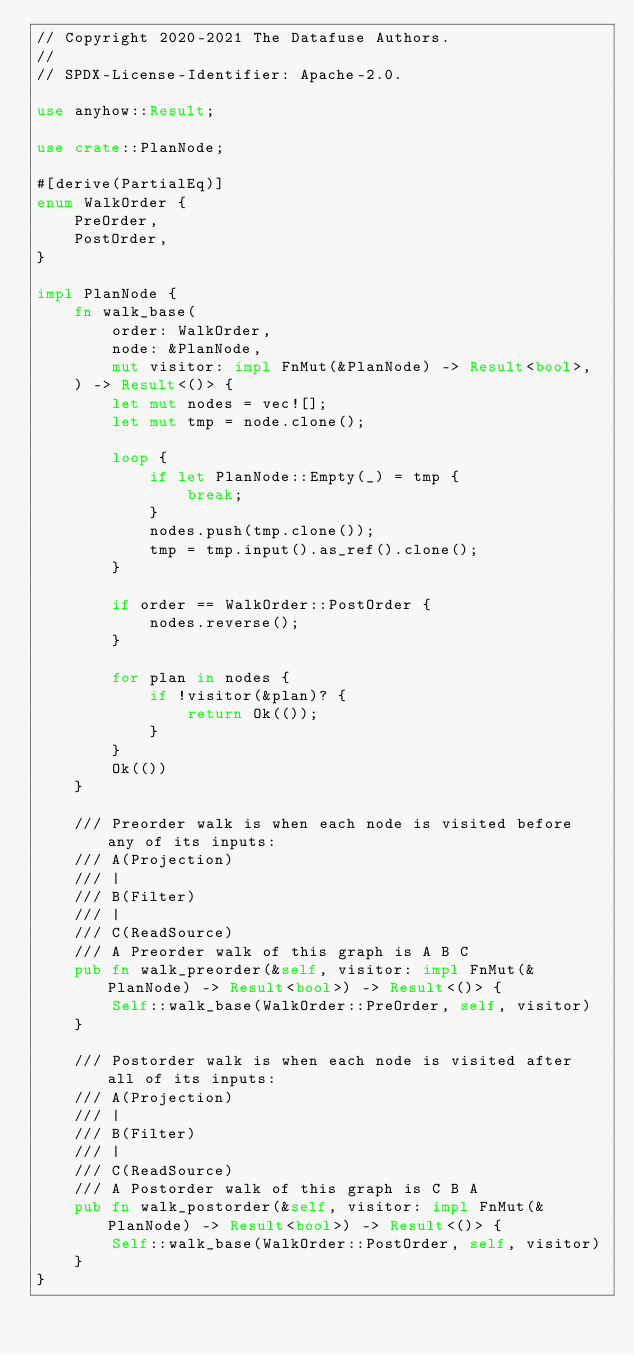Convert code to text. <code><loc_0><loc_0><loc_500><loc_500><_Rust_>// Copyright 2020-2021 The Datafuse Authors.
//
// SPDX-License-Identifier: Apache-2.0.

use anyhow::Result;

use crate::PlanNode;

#[derive(PartialEq)]
enum WalkOrder {
    PreOrder,
    PostOrder,
}

impl PlanNode {
    fn walk_base(
        order: WalkOrder,
        node: &PlanNode,
        mut visitor: impl FnMut(&PlanNode) -> Result<bool>,
    ) -> Result<()> {
        let mut nodes = vec![];
        let mut tmp = node.clone();

        loop {
            if let PlanNode::Empty(_) = tmp {
                break;
            }
            nodes.push(tmp.clone());
            tmp = tmp.input().as_ref().clone();
        }

        if order == WalkOrder::PostOrder {
            nodes.reverse();
        }

        for plan in nodes {
            if !visitor(&plan)? {
                return Ok(());
            }
        }
        Ok(())
    }

    /// Preorder walk is when each node is visited before any of its inputs:
    /// A(Projection)
    /// |
    /// B(Filter)
    /// |
    /// C(ReadSource)
    /// A Preorder walk of this graph is A B C
    pub fn walk_preorder(&self, visitor: impl FnMut(&PlanNode) -> Result<bool>) -> Result<()> {
        Self::walk_base(WalkOrder::PreOrder, self, visitor)
    }

    /// Postorder walk is when each node is visited after all of its inputs:
    /// A(Projection)
    /// |
    /// B(Filter)
    /// |
    /// C(ReadSource)
    /// A Postorder walk of this graph is C B A
    pub fn walk_postorder(&self, visitor: impl FnMut(&PlanNode) -> Result<bool>) -> Result<()> {
        Self::walk_base(WalkOrder::PostOrder, self, visitor)
    }
}
</code> 